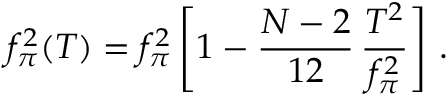Convert formula to latex. <formula><loc_0><loc_0><loc_500><loc_500>f _ { \pi } ^ { 2 } ( T ) = f _ { \pi } ^ { 2 } \left [ 1 - \frac { N - 2 } { 1 2 } \, \frac { T ^ { 2 } } { f _ { \pi } ^ { 2 } } \right ] \, .</formula> 